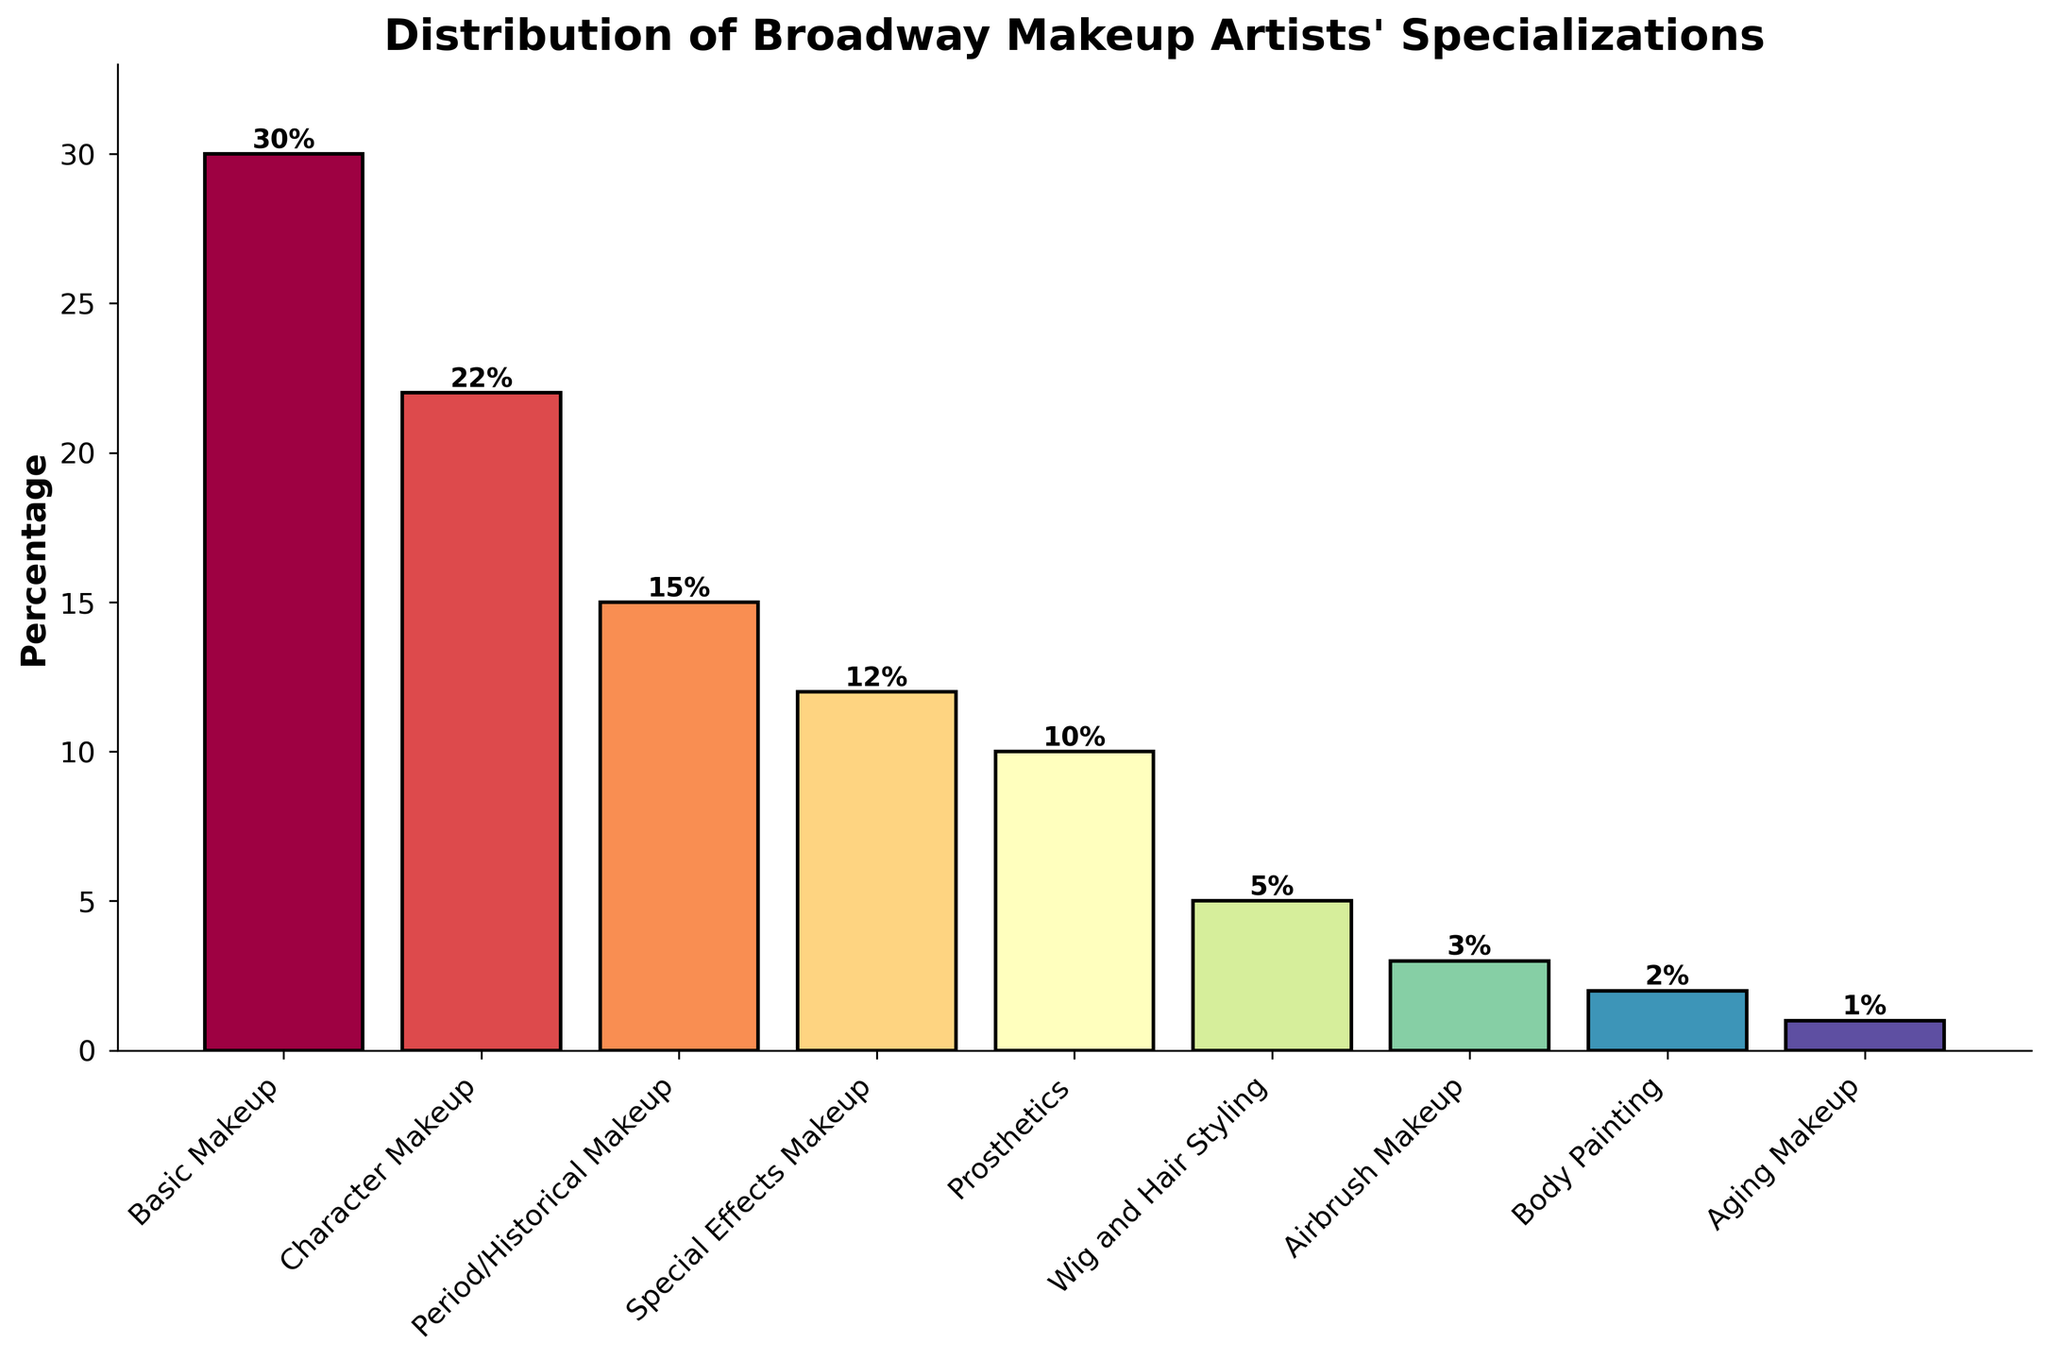Which specialization has the highest percentage? The highest bar indicates the specialization with the greatest percentage. By checking the heights, Basic Makeup has the highest percentage.
Answer: Basic Makeup Which specialization has the lowest percentage? The smallest bar shows the specialization with the least percentage. Aging Makeup's bar is the smallest.
Answer: Aging Makeup How many specializations have a percentage below 10%? Identify bars where the percentage is less than 10%. There are 5 bars below 10%: Wig and Hair Styling, Airbrush Makeup, Body Painting, and Aging Makeup.
Answer: 4 How much more common is Basic Makeup compared to Prosthetics? Subtract Prosthetics' percentage from Basic Makeup's percentage (30% - 10%).
Answer: 20% What is the average percentage of all specializations? Sum all percentages (30 + 22 + 15 + 12 + 10 + 5 + 3 + 2 + 1 = 100) and divide by 9 (the total number of specializations). The average is 100/9.
Answer: 11.11% Which two specializations combined account for half of the chart’s total percentage? Find two categories that sum to 50%. Basic Makeup (30%) and Character Makeup (22%) together make 52%.
Answer: Basic Makeup and Character Makeup Is the percentage for Wig and Hair Styling greater than that for Airbrush Makeup? Compare the heights. Wig and Hair Styling is 5%, and Airbrush Makeup is 3%.
Answer: Yes Which specialization ranks third in terms of percentage? Order the bars from highest to lowest. The third highest percentage is Period/Historical Makeup at 15%.
Answer: Period/Historical Makeup How much greater is the combined percentage for Basic Makeup and Special Effects Makeup compared to Character Makeup? First sum Basic Makeup and Special Effects Makeup (30% + 12% = 42%). Then subtract the Character Makeup percentage (42% - 22%).
Answer: 20% What is the difference in percentage between Body Painting and Aging Makeup? Subtract Aging Makeup's percentage from Body Painting's percentage (2% - 1%).
Answer: 1% 